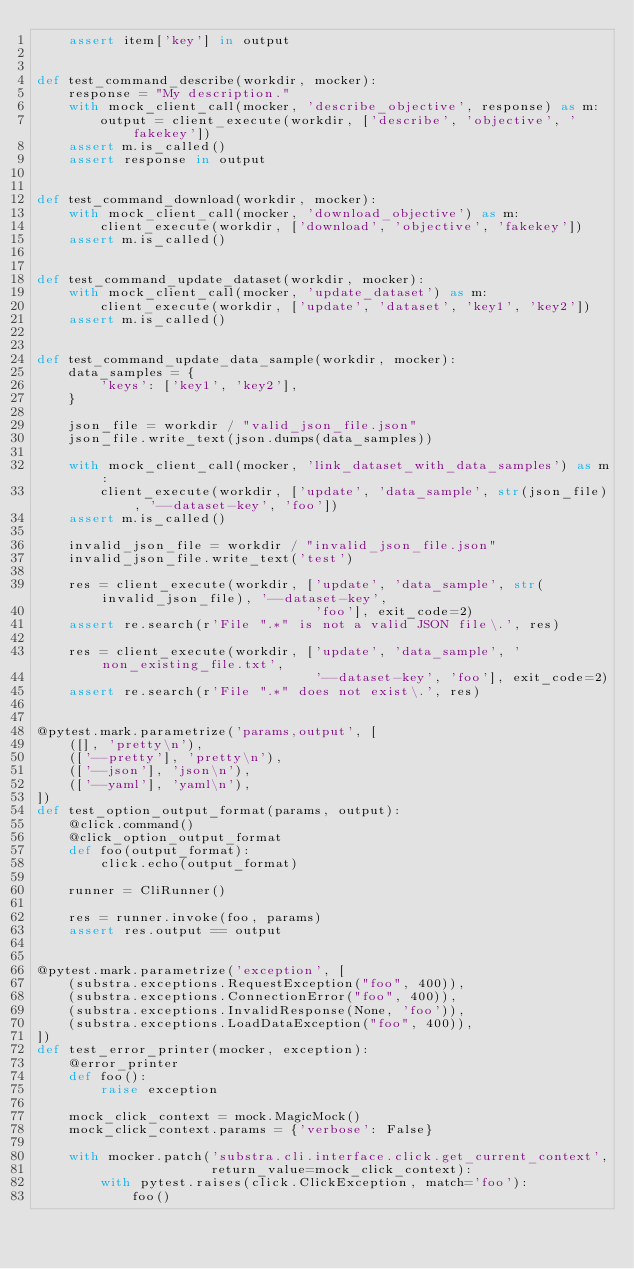Convert code to text. <code><loc_0><loc_0><loc_500><loc_500><_Python_>    assert item['key'] in output


def test_command_describe(workdir, mocker):
    response = "My description."
    with mock_client_call(mocker, 'describe_objective', response) as m:
        output = client_execute(workdir, ['describe', 'objective', 'fakekey'])
    assert m.is_called()
    assert response in output


def test_command_download(workdir, mocker):
    with mock_client_call(mocker, 'download_objective') as m:
        client_execute(workdir, ['download', 'objective', 'fakekey'])
    assert m.is_called()


def test_command_update_dataset(workdir, mocker):
    with mock_client_call(mocker, 'update_dataset') as m:
        client_execute(workdir, ['update', 'dataset', 'key1', 'key2'])
    assert m.is_called()


def test_command_update_data_sample(workdir, mocker):
    data_samples = {
        'keys': ['key1', 'key2'],
    }

    json_file = workdir / "valid_json_file.json"
    json_file.write_text(json.dumps(data_samples))

    with mock_client_call(mocker, 'link_dataset_with_data_samples') as m:
        client_execute(workdir, ['update', 'data_sample', str(json_file), '--dataset-key', 'foo'])
    assert m.is_called()

    invalid_json_file = workdir / "invalid_json_file.json"
    invalid_json_file.write_text('test')

    res = client_execute(workdir, ['update', 'data_sample', str(invalid_json_file), '--dataset-key',
                                   'foo'], exit_code=2)
    assert re.search(r'File ".*" is not a valid JSON file\.', res)

    res = client_execute(workdir, ['update', 'data_sample', 'non_existing_file.txt',
                                   '--dataset-key', 'foo'], exit_code=2)
    assert re.search(r'File ".*" does not exist\.', res)


@pytest.mark.parametrize('params,output', [
    ([], 'pretty\n'),
    (['--pretty'], 'pretty\n'),
    (['--json'], 'json\n'),
    (['--yaml'], 'yaml\n'),
])
def test_option_output_format(params, output):
    @click.command()
    @click_option_output_format
    def foo(output_format):
        click.echo(output_format)

    runner = CliRunner()

    res = runner.invoke(foo, params)
    assert res.output == output


@pytest.mark.parametrize('exception', [
    (substra.exceptions.RequestException("foo", 400)),
    (substra.exceptions.ConnectionError("foo", 400)),
    (substra.exceptions.InvalidResponse(None, 'foo')),
    (substra.exceptions.LoadDataException("foo", 400)),
])
def test_error_printer(mocker, exception):
    @error_printer
    def foo():
        raise exception

    mock_click_context = mock.MagicMock()
    mock_click_context.params = {'verbose': False}

    with mocker.patch('substra.cli.interface.click.get_current_context',
                      return_value=mock_click_context):
        with pytest.raises(click.ClickException, match='foo'):
            foo()
</code> 